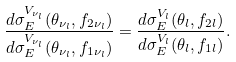<formula> <loc_0><loc_0><loc_500><loc_500>\frac { d \sigma _ { E } ^ { V _ { \nu _ { l } } } ( \theta _ { \nu _ { l } } , f _ { 2 \nu _ { l } } ) } { d \sigma _ { E } ^ { V _ { \nu _ { l } } } ( \theta _ { \nu _ { l } } , f _ { 1 \nu _ { l } } ) } = \frac { d \sigma _ { E } ^ { V _ { l } } ( \theta _ { l } , f _ { 2 l } ) } { d \sigma _ { E } ^ { V _ { l } } ( \theta _ { l } , f _ { 1 l } ) } .</formula> 